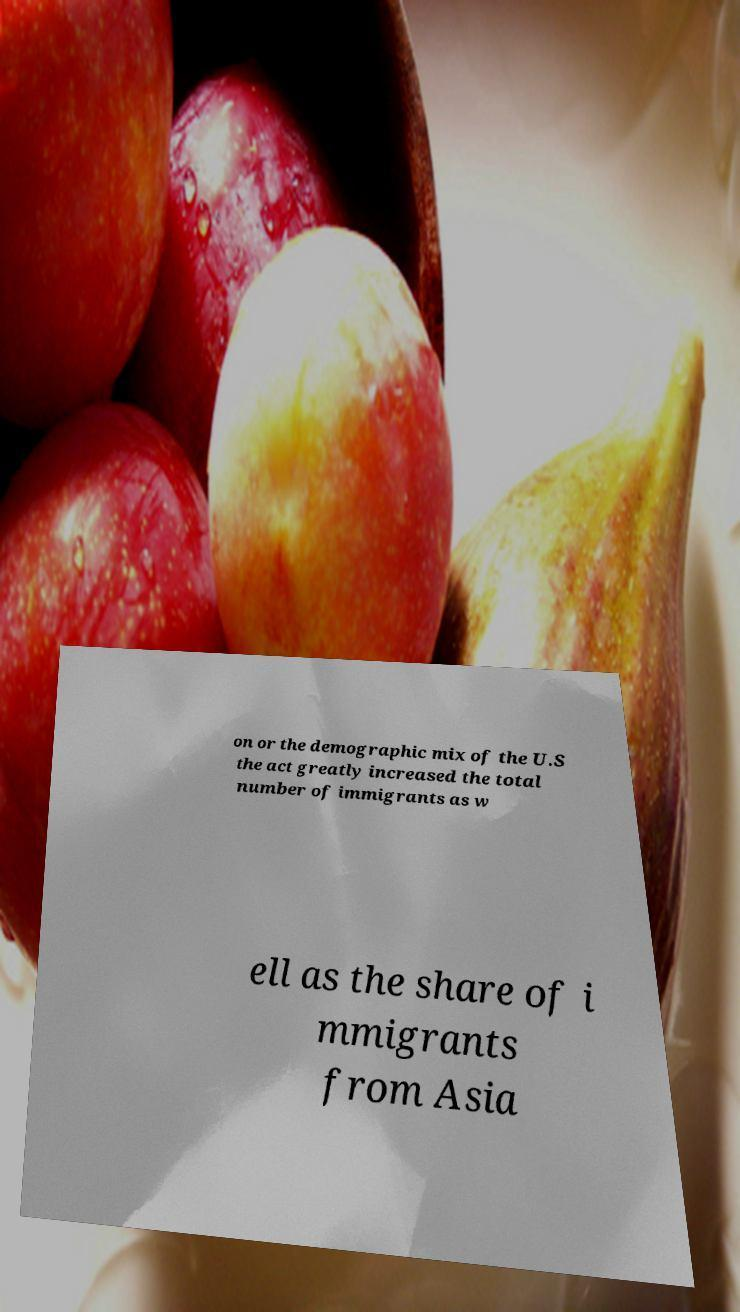Please read and relay the text visible in this image. What does it say? on or the demographic mix of the U.S the act greatly increased the total number of immigrants as w ell as the share of i mmigrants from Asia 